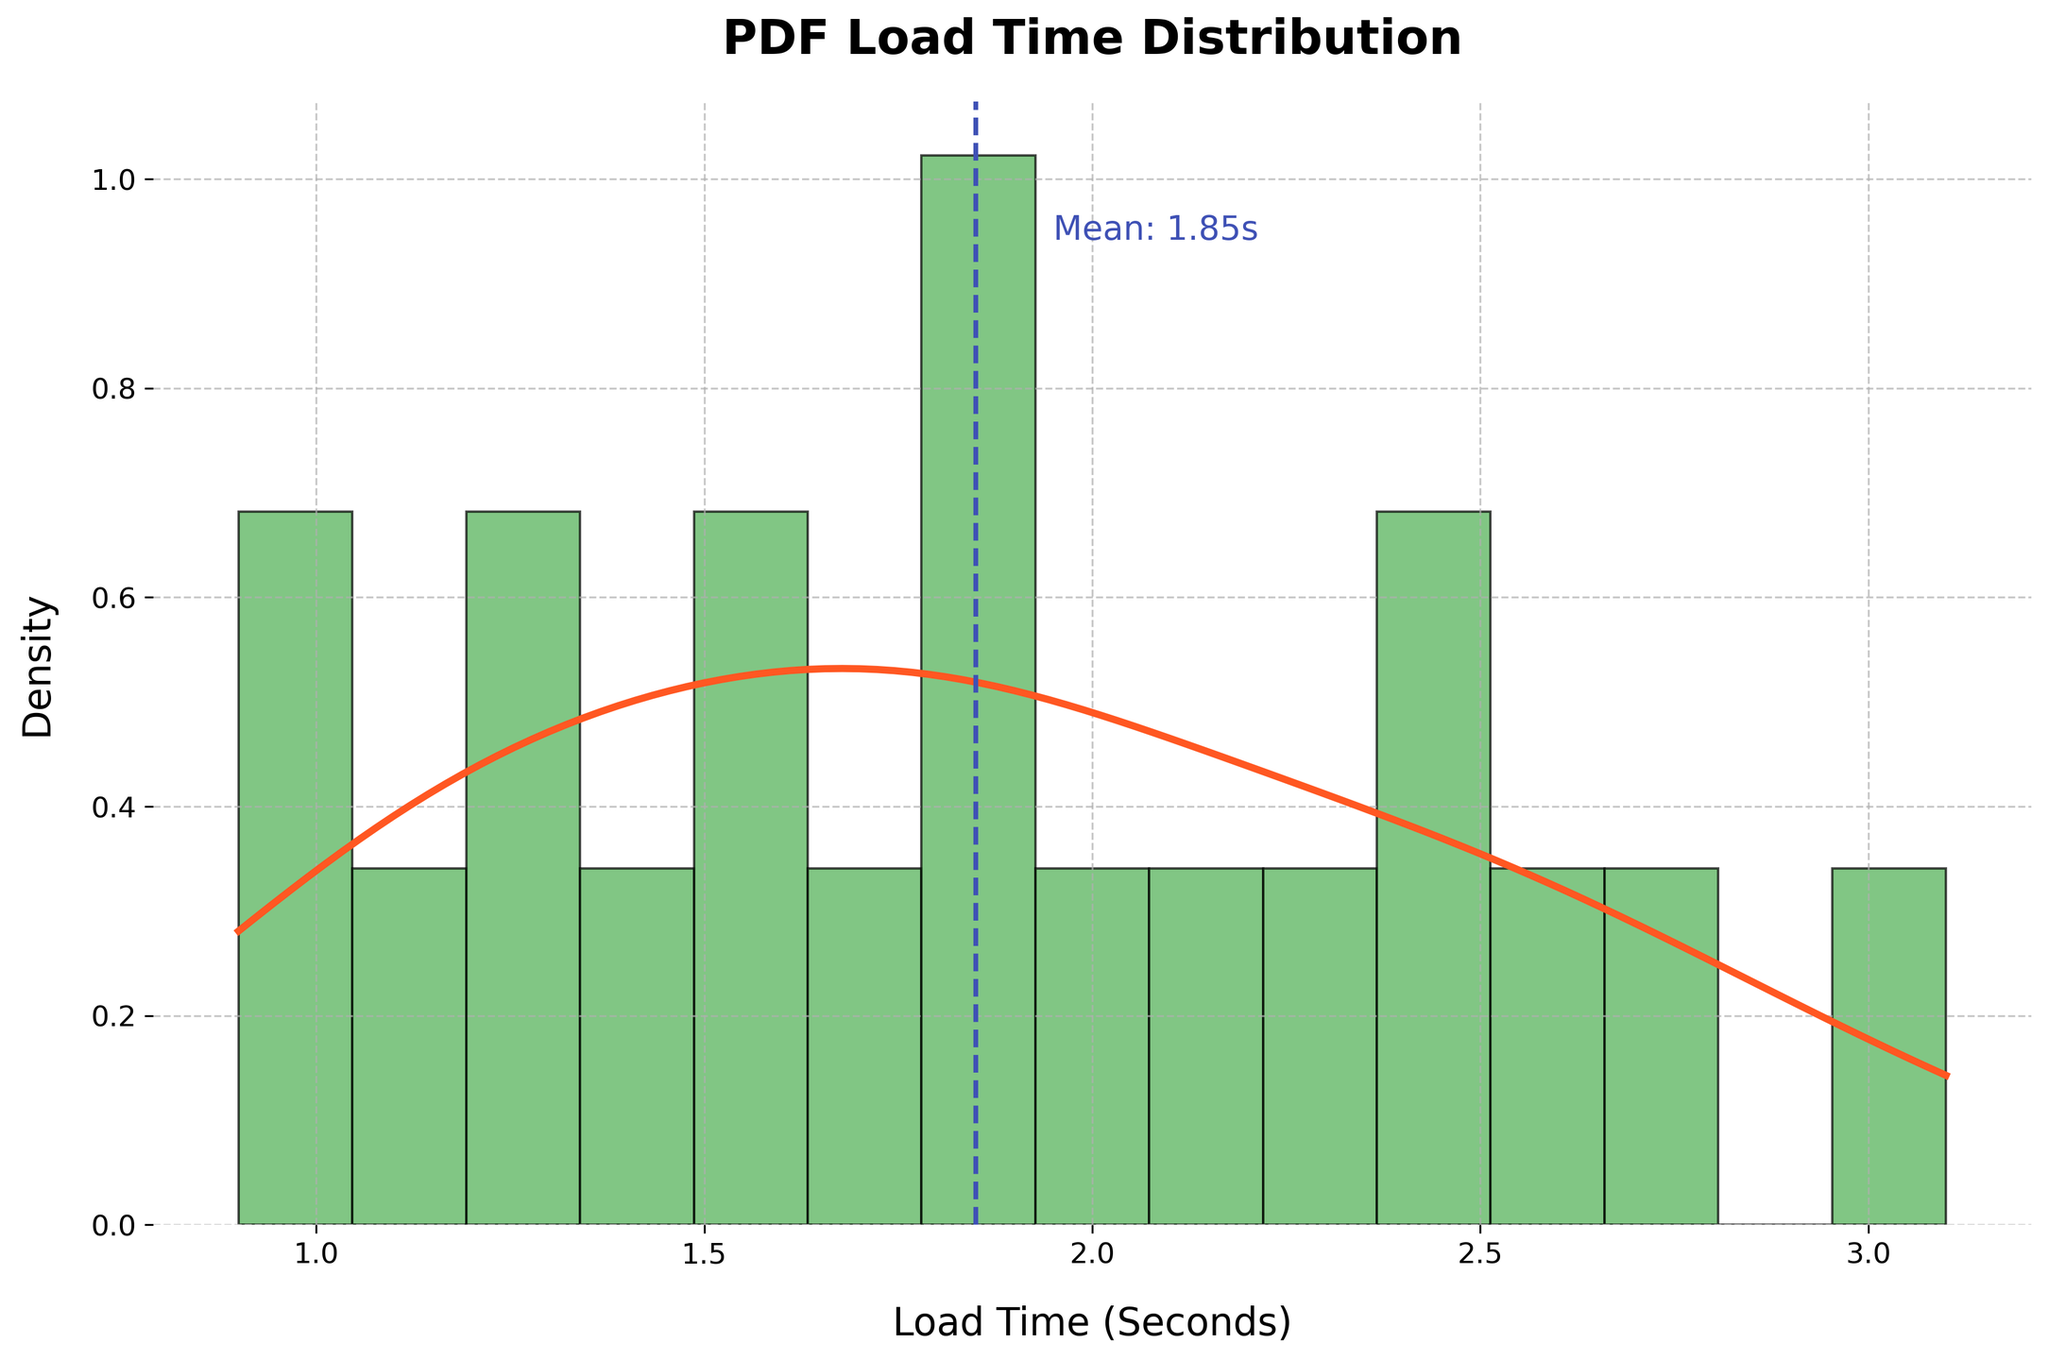What is the title of the figure? The title is usually found at the top of the figure; in this case, it states "PDF Load Time Distribution".
Answer: PDF Load Time Distribution What does the x-axis represent? The x-axis label indicates the variable being measured; here, it shows "Load Time (Seconds)".
Answer: Load Time (Seconds) What color is the density curve? The density curve in the figure is drawn in a distinct color to differentiate it from the histogram; it is in orange.
Answer: Orange What is the mean load time indicated by the vertical dashed line? The vertical dashed line represents the mean load time, which is also annotated next to the line. The mean load time is approximately 1.95 seconds.
Answer: 1.95 seconds What range of load times has the highest density on the histogram? To find the range with the highest density, observe where the tallest bars occur in the histogram, which appears to be between 1.0 and 2.0 seconds.
Answer: 1.0 to 2.0 seconds What's the sum of load times for devices with available speed marks of 10 Mbps and above? Devices with speeds of 10 Mbps and above have load times: 1.8, 1.5, 1.2, 0.9, 1.0, 1.7, 1.9, 1.8, and 1.3 seconds. Summing these: 1.8+1.5+1.2+0.9+1.0+1.7+1.9+1.8+1.3 = 13.1 seconds.
Answer: 13.1 seconds Which is higher, the density at 1.0 seconds or at 2.0 seconds? Compare the heights of the density curve at these points. The height at 1.0 seconds is greater than at 2.0 seconds.
Answer: Density at 1.0 seconds Is the density curve higher or lower than the histogram at 2.0 seconds? Look at the relative height of the density curve compared to the corresponding bar in the histogram at 2.0 seconds. The density curve is higher.
Answer: Higher What does the KDE line represent in this figure? The KDE (Kernel Density Estimation) line represents the smoothed distribution of PDF load times, providing an estimate of the probability density function.
Answer: Smoothed distribution Where is the histogram edge color black, and why might this be important? The histogram edge color is black, which helps to clearly delineate the individual bars, making the distribution easier to interpret.
Answer: To delineate bars clearly 